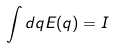<formula> <loc_0><loc_0><loc_500><loc_500>\int d q E ( q ) = I</formula> 